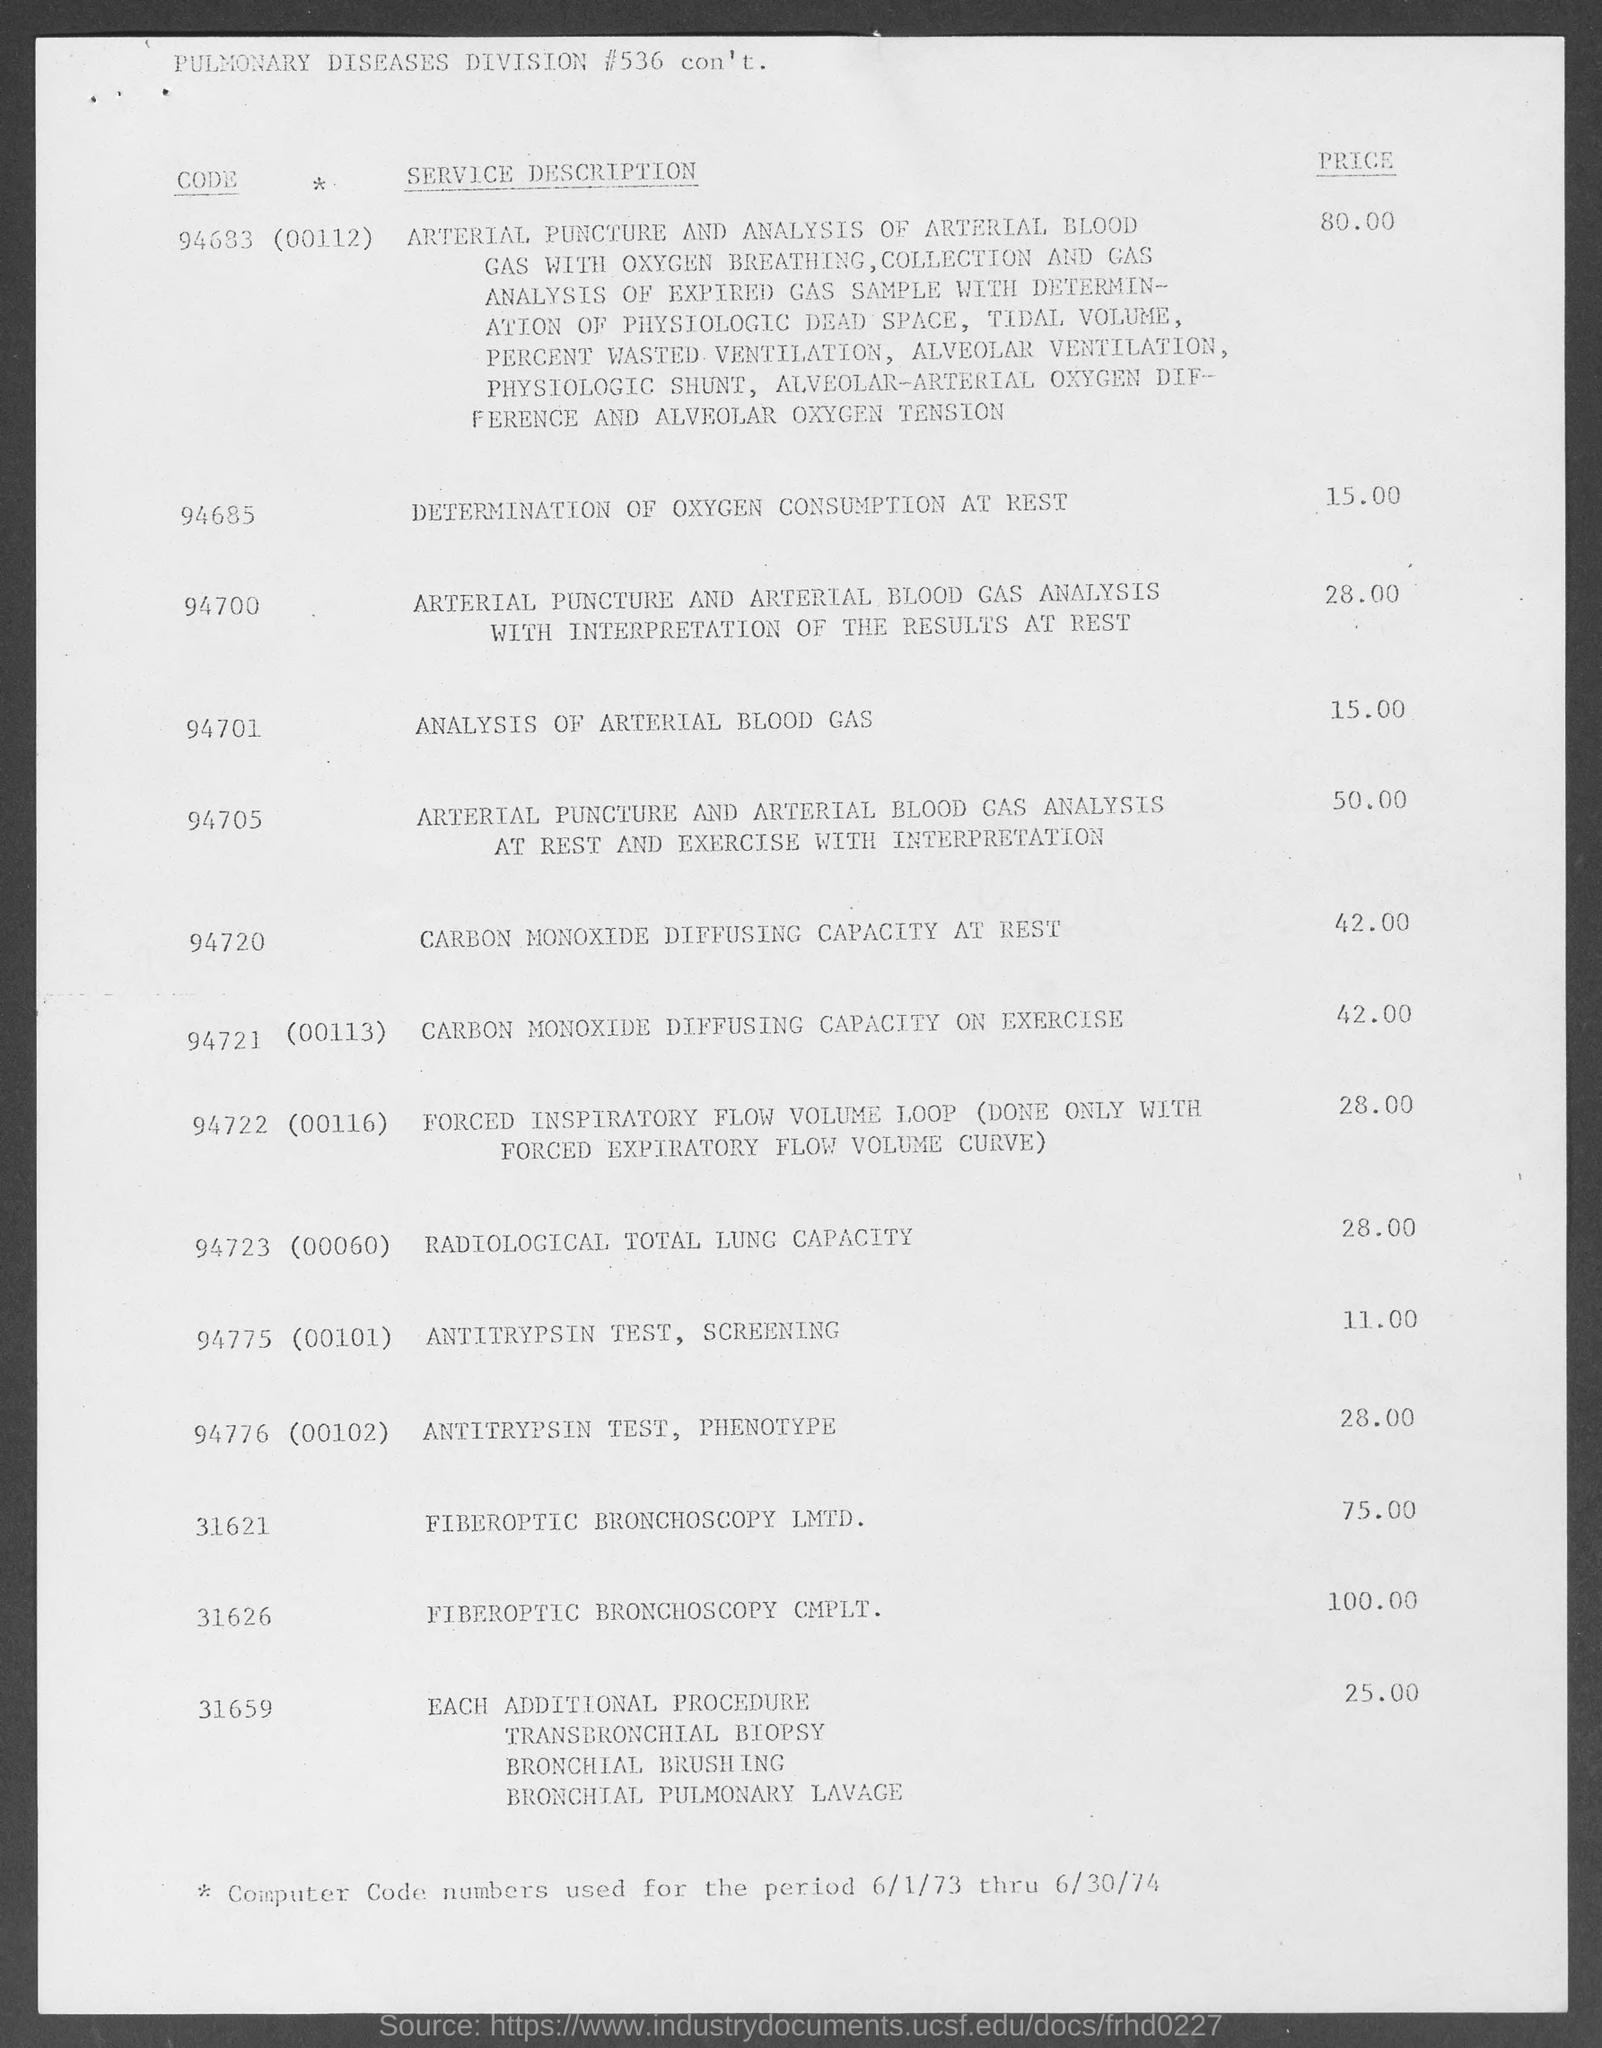Highlight a few significant elements in this photo. The code for radiological total lung capacity is 94723 (00060). The cost of an analysis of arterial blood gas is 15. I'm sorry, but the text you provided appears to be unrelated to any specific topic or question. It seems to be a string of numbers and letters without any context or meaning. Without further information, it is not possible for me to provide a clear and accurate answer. 